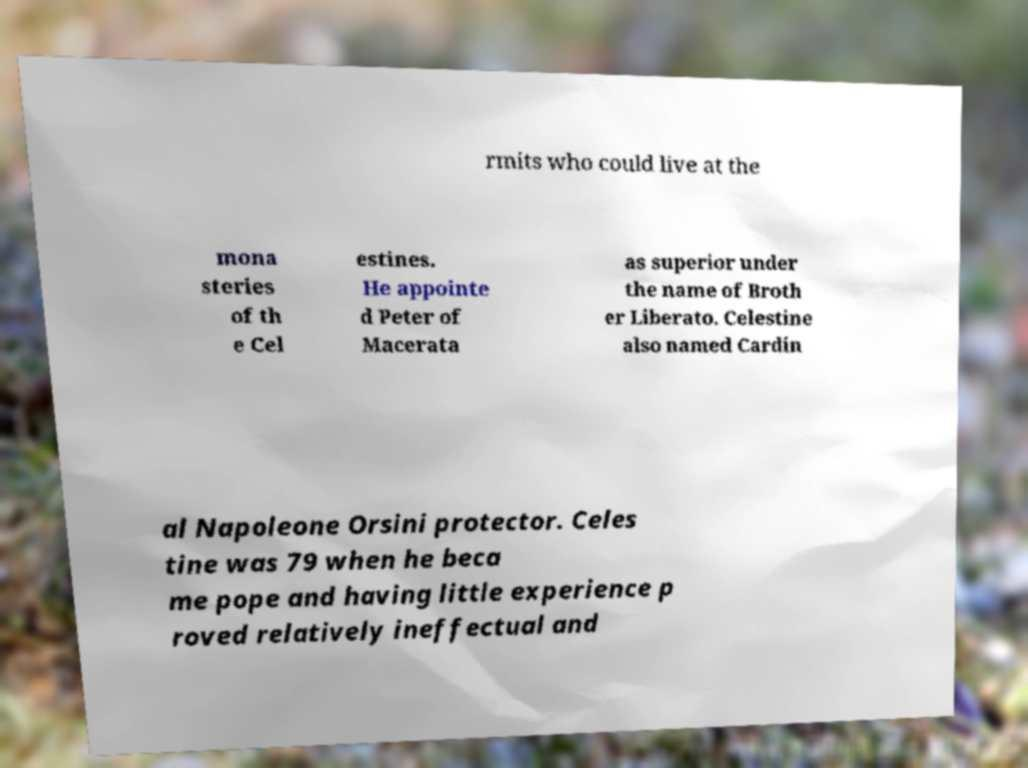For documentation purposes, I need the text within this image transcribed. Could you provide that? rmits who could live at the mona steries of th e Cel estines. He appointe d Peter of Macerata as superior under the name of Broth er Liberato. Celestine also named Cardin al Napoleone Orsini protector. Celes tine was 79 when he beca me pope and having little experience p roved relatively ineffectual and 